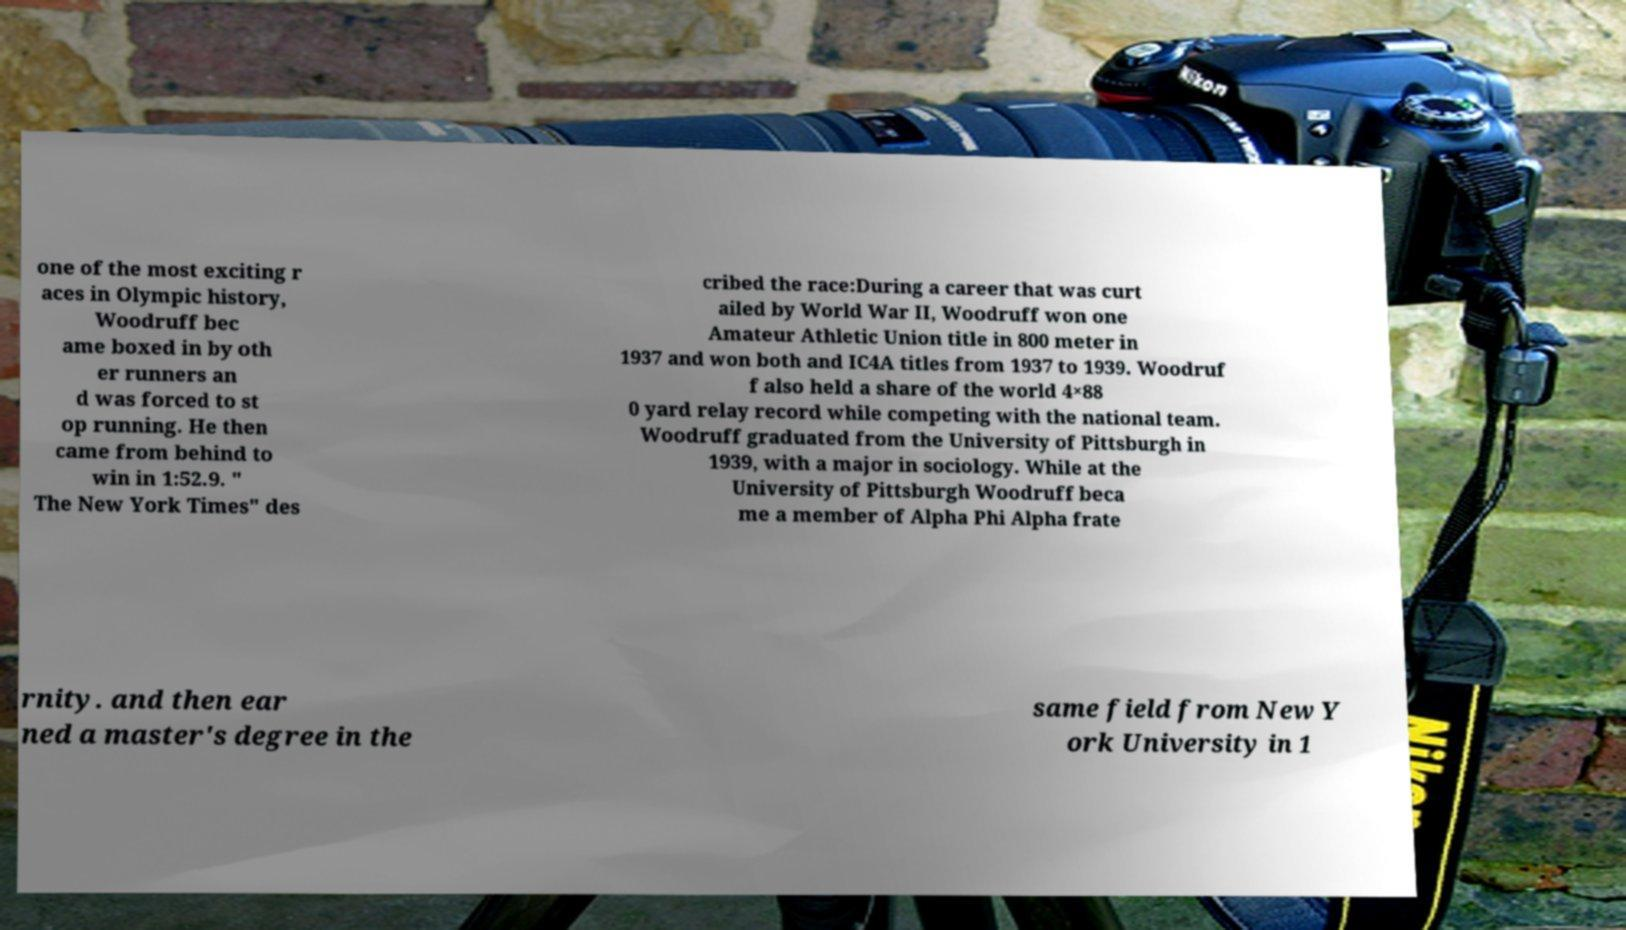Can you read and provide the text displayed in the image?This photo seems to have some interesting text. Can you extract and type it out for me? one of the most exciting r aces in Olympic history, Woodruff bec ame boxed in by oth er runners an d was forced to st op running. He then came from behind to win in 1:52.9. " The New York Times" des cribed the race:During a career that was curt ailed by World War II, Woodruff won one Amateur Athletic Union title in 800 meter in 1937 and won both and IC4A titles from 1937 to 1939. Woodruf f also held a share of the world 4×88 0 yard relay record while competing with the national team. Woodruff graduated from the University of Pittsburgh in 1939, with a major in sociology. While at the University of Pittsburgh Woodruff beca me a member of Alpha Phi Alpha frate rnity. and then ear ned a master's degree in the same field from New Y ork University in 1 